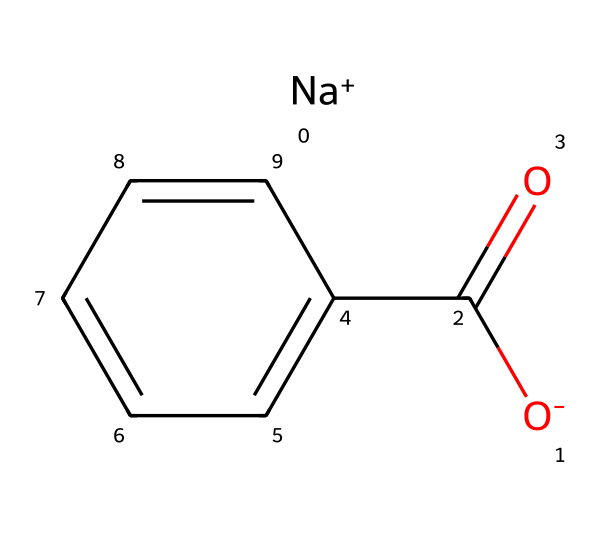What is the molecular formula of sodium benzoate? The molecular structure indicates sodium (Na), a benzoate ion (C7H5O2), and combines them, yielding the molecular formula C7H5NaO2.
Answer: C7H5NaO2 How many carbon atoms are in sodium benzoate? In the molecular structure of sodium benzoate, there are seven carbon atoms represented in the benzoate part of the molecule.
Answer: 7 What functional group is present in sodium benzoate? The structure contains a carboxylate group (–COO–), which is characteristic of benzoate, indicating it has a functional group associated with acidity and preservation.
Answer: carboxylate What charge does the sodium ion carry? The sodium ion (Na+) in the structure is indicated as positively charged, which it exhibits to balance out the charge of the benzoate ion.
Answer: positive Why is sodium benzoate used as a food preservative? Sodium benzoate inhibits the growth of mold, yeast, and some bacteria by lowering the pH and making the environment less favorable for microbial growth, effectively prolonging shelf-life.
Answer: inhibits microbial growth What type of compound is sodium benzoate classified as? Sodium benzoate is categorized as a food additive and specifically as a preservative due to its ability to prevent spoilage in various food products.
Answer: preservative How many oxygen atoms are present in sodium benzoate? Analyzing the structure reveals that there are two oxygen atoms within the carboxylate functional group in sodium benzoate.
Answer: 2 